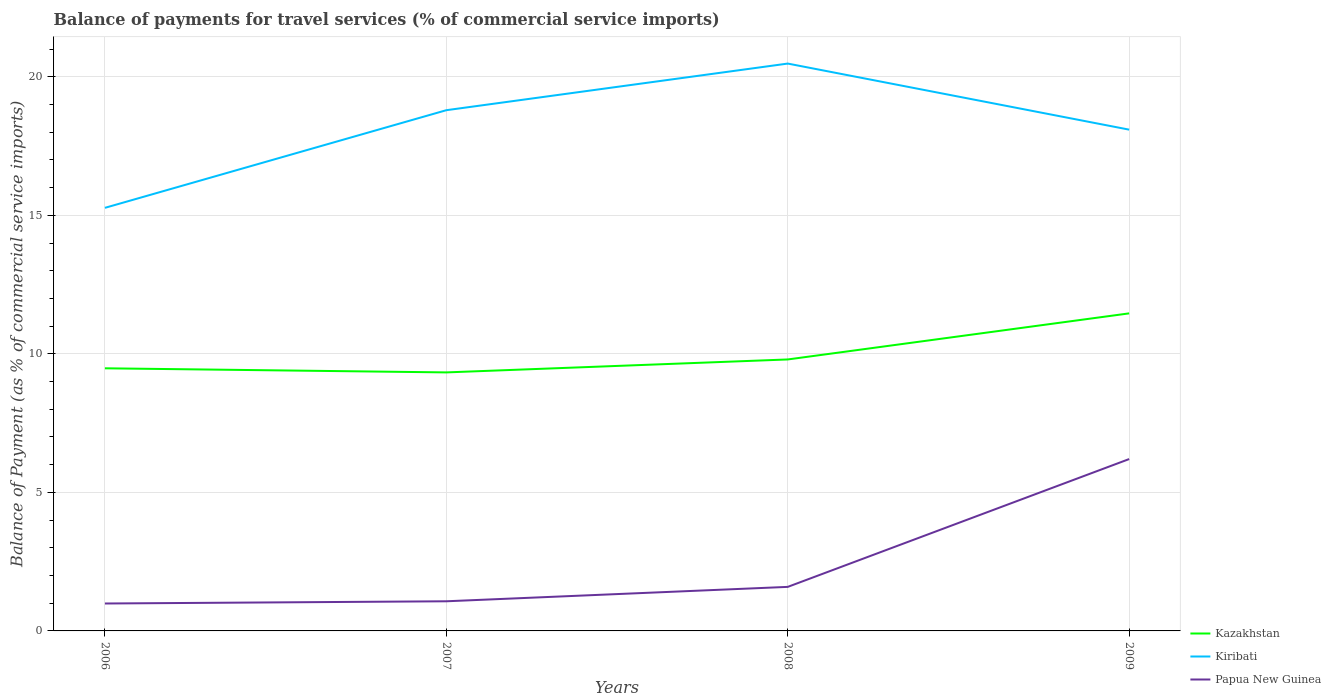Does the line corresponding to Papua New Guinea intersect with the line corresponding to Kazakhstan?
Provide a short and direct response. No. Across all years, what is the maximum balance of payments for travel services in Kazakhstan?
Keep it short and to the point. 9.33. In which year was the balance of payments for travel services in Papua New Guinea maximum?
Provide a succinct answer. 2006. What is the total balance of payments for travel services in Papua New Guinea in the graph?
Your response must be concise. -0.52. What is the difference between the highest and the second highest balance of payments for travel services in Kazakhstan?
Offer a very short reply. 2.13. What is the difference between the highest and the lowest balance of payments for travel services in Papua New Guinea?
Offer a very short reply. 1. Is the balance of payments for travel services in Kazakhstan strictly greater than the balance of payments for travel services in Papua New Guinea over the years?
Ensure brevity in your answer.  No. How many years are there in the graph?
Your answer should be compact. 4. Does the graph contain any zero values?
Provide a short and direct response. No. Where does the legend appear in the graph?
Keep it short and to the point. Bottom right. What is the title of the graph?
Make the answer very short. Balance of payments for travel services (% of commercial service imports). What is the label or title of the X-axis?
Keep it short and to the point. Years. What is the label or title of the Y-axis?
Ensure brevity in your answer.  Balance of Payment (as % of commercial service imports). What is the Balance of Payment (as % of commercial service imports) in Kazakhstan in 2006?
Give a very brief answer. 9.48. What is the Balance of Payment (as % of commercial service imports) in Kiribati in 2006?
Offer a very short reply. 15.27. What is the Balance of Payment (as % of commercial service imports) in Papua New Guinea in 2006?
Offer a very short reply. 0.99. What is the Balance of Payment (as % of commercial service imports) in Kazakhstan in 2007?
Make the answer very short. 9.33. What is the Balance of Payment (as % of commercial service imports) in Kiribati in 2007?
Provide a succinct answer. 18.79. What is the Balance of Payment (as % of commercial service imports) of Papua New Guinea in 2007?
Offer a terse response. 1.07. What is the Balance of Payment (as % of commercial service imports) of Kazakhstan in 2008?
Provide a short and direct response. 9.8. What is the Balance of Payment (as % of commercial service imports) of Kiribati in 2008?
Offer a very short reply. 20.48. What is the Balance of Payment (as % of commercial service imports) in Papua New Guinea in 2008?
Make the answer very short. 1.59. What is the Balance of Payment (as % of commercial service imports) of Kazakhstan in 2009?
Ensure brevity in your answer.  11.46. What is the Balance of Payment (as % of commercial service imports) in Kiribati in 2009?
Ensure brevity in your answer.  18.09. What is the Balance of Payment (as % of commercial service imports) in Papua New Guinea in 2009?
Make the answer very short. 6.2. Across all years, what is the maximum Balance of Payment (as % of commercial service imports) of Kazakhstan?
Provide a succinct answer. 11.46. Across all years, what is the maximum Balance of Payment (as % of commercial service imports) in Kiribati?
Offer a terse response. 20.48. Across all years, what is the maximum Balance of Payment (as % of commercial service imports) of Papua New Guinea?
Offer a very short reply. 6.2. Across all years, what is the minimum Balance of Payment (as % of commercial service imports) of Kazakhstan?
Give a very brief answer. 9.33. Across all years, what is the minimum Balance of Payment (as % of commercial service imports) of Kiribati?
Your answer should be very brief. 15.27. Across all years, what is the minimum Balance of Payment (as % of commercial service imports) in Papua New Guinea?
Your answer should be compact. 0.99. What is the total Balance of Payment (as % of commercial service imports) of Kazakhstan in the graph?
Keep it short and to the point. 40.07. What is the total Balance of Payment (as % of commercial service imports) in Kiribati in the graph?
Provide a short and direct response. 72.63. What is the total Balance of Payment (as % of commercial service imports) in Papua New Guinea in the graph?
Your response must be concise. 9.85. What is the difference between the Balance of Payment (as % of commercial service imports) in Kazakhstan in 2006 and that in 2007?
Make the answer very short. 0.15. What is the difference between the Balance of Payment (as % of commercial service imports) in Kiribati in 2006 and that in 2007?
Make the answer very short. -3.52. What is the difference between the Balance of Payment (as % of commercial service imports) in Papua New Guinea in 2006 and that in 2007?
Provide a succinct answer. -0.08. What is the difference between the Balance of Payment (as % of commercial service imports) of Kazakhstan in 2006 and that in 2008?
Keep it short and to the point. -0.32. What is the difference between the Balance of Payment (as % of commercial service imports) in Kiribati in 2006 and that in 2008?
Your response must be concise. -5.21. What is the difference between the Balance of Payment (as % of commercial service imports) of Papua New Guinea in 2006 and that in 2008?
Offer a very short reply. -0.6. What is the difference between the Balance of Payment (as % of commercial service imports) in Kazakhstan in 2006 and that in 2009?
Provide a succinct answer. -1.98. What is the difference between the Balance of Payment (as % of commercial service imports) of Kiribati in 2006 and that in 2009?
Provide a short and direct response. -2.82. What is the difference between the Balance of Payment (as % of commercial service imports) of Papua New Guinea in 2006 and that in 2009?
Make the answer very short. -5.21. What is the difference between the Balance of Payment (as % of commercial service imports) in Kazakhstan in 2007 and that in 2008?
Keep it short and to the point. -0.47. What is the difference between the Balance of Payment (as % of commercial service imports) in Kiribati in 2007 and that in 2008?
Offer a terse response. -1.68. What is the difference between the Balance of Payment (as % of commercial service imports) of Papua New Guinea in 2007 and that in 2008?
Keep it short and to the point. -0.52. What is the difference between the Balance of Payment (as % of commercial service imports) in Kazakhstan in 2007 and that in 2009?
Offer a very short reply. -2.13. What is the difference between the Balance of Payment (as % of commercial service imports) of Kiribati in 2007 and that in 2009?
Your response must be concise. 0.7. What is the difference between the Balance of Payment (as % of commercial service imports) in Papua New Guinea in 2007 and that in 2009?
Your response must be concise. -5.13. What is the difference between the Balance of Payment (as % of commercial service imports) in Kazakhstan in 2008 and that in 2009?
Ensure brevity in your answer.  -1.66. What is the difference between the Balance of Payment (as % of commercial service imports) of Kiribati in 2008 and that in 2009?
Provide a short and direct response. 2.38. What is the difference between the Balance of Payment (as % of commercial service imports) of Papua New Guinea in 2008 and that in 2009?
Your answer should be very brief. -4.61. What is the difference between the Balance of Payment (as % of commercial service imports) in Kazakhstan in 2006 and the Balance of Payment (as % of commercial service imports) in Kiribati in 2007?
Offer a terse response. -9.31. What is the difference between the Balance of Payment (as % of commercial service imports) of Kazakhstan in 2006 and the Balance of Payment (as % of commercial service imports) of Papua New Guinea in 2007?
Make the answer very short. 8.41. What is the difference between the Balance of Payment (as % of commercial service imports) in Kiribati in 2006 and the Balance of Payment (as % of commercial service imports) in Papua New Guinea in 2007?
Offer a very short reply. 14.2. What is the difference between the Balance of Payment (as % of commercial service imports) of Kazakhstan in 2006 and the Balance of Payment (as % of commercial service imports) of Kiribati in 2008?
Your answer should be very brief. -11. What is the difference between the Balance of Payment (as % of commercial service imports) in Kazakhstan in 2006 and the Balance of Payment (as % of commercial service imports) in Papua New Guinea in 2008?
Offer a very short reply. 7.89. What is the difference between the Balance of Payment (as % of commercial service imports) in Kiribati in 2006 and the Balance of Payment (as % of commercial service imports) in Papua New Guinea in 2008?
Keep it short and to the point. 13.68. What is the difference between the Balance of Payment (as % of commercial service imports) in Kazakhstan in 2006 and the Balance of Payment (as % of commercial service imports) in Kiribati in 2009?
Your answer should be very brief. -8.61. What is the difference between the Balance of Payment (as % of commercial service imports) of Kazakhstan in 2006 and the Balance of Payment (as % of commercial service imports) of Papua New Guinea in 2009?
Give a very brief answer. 3.28. What is the difference between the Balance of Payment (as % of commercial service imports) of Kiribati in 2006 and the Balance of Payment (as % of commercial service imports) of Papua New Guinea in 2009?
Your answer should be compact. 9.07. What is the difference between the Balance of Payment (as % of commercial service imports) of Kazakhstan in 2007 and the Balance of Payment (as % of commercial service imports) of Kiribati in 2008?
Keep it short and to the point. -11.15. What is the difference between the Balance of Payment (as % of commercial service imports) of Kazakhstan in 2007 and the Balance of Payment (as % of commercial service imports) of Papua New Guinea in 2008?
Provide a short and direct response. 7.74. What is the difference between the Balance of Payment (as % of commercial service imports) in Kiribati in 2007 and the Balance of Payment (as % of commercial service imports) in Papua New Guinea in 2008?
Give a very brief answer. 17.2. What is the difference between the Balance of Payment (as % of commercial service imports) of Kazakhstan in 2007 and the Balance of Payment (as % of commercial service imports) of Kiribati in 2009?
Give a very brief answer. -8.76. What is the difference between the Balance of Payment (as % of commercial service imports) in Kazakhstan in 2007 and the Balance of Payment (as % of commercial service imports) in Papua New Guinea in 2009?
Your answer should be compact. 3.13. What is the difference between the Balance of Payment (as % of commercial service imports) in Kiribati in 2007 and the Balance of Payment (as % of commercial service imports) in Papua New Guinea in 2009?
Your answer should be very brief. 12.59. What is the difference between the Balance of Payment (as % of commercial service imports) in Kazakhstan in 2008 and the Balance of Payment (as % of commercial service imports) in Kiribati in 2009?
Make the answer very short. -8.29. What is the difference between the Balance of Payment (as % of commercial service imports) in Kazakhstan in 2008 and the Balance of Payment (as % of commercial service imports) in Papua New Guinea in 2009?
Give a very brief answer. 3.59. What is the difference between the Balance of Payment (as % of commercial service imports) in Kiribati in 2008 and the Balance of Payment (as % of commercial service imports) in Papua New Guinea in 2009?
Keep it short and to the point. 14.27. What is the average Balance of Payment (as % of commercial service imports) of Kazakhstan per year?
Provide a short and direct response. 10.02. What is the average Balance of Payment (as % of commercial service imports) in Kiribati per year?
Offer a very short reply. 18.16. What is the average Balance of Payment (as % of commercial service imports) of Papua New Guinea per year?
Provide a short and direct response. 2.46. In the year 2006, what is the difference between the Balance of Payment (as % of commercial service imports) of Kazakhstan and Balance of Payment (as % of commercial service imports) of Kiribati?
Keep it short and to the point. -5.79. In the year 2006, what is the difference between the Balance of Payment (as % of commercial service imports) of Kazakhstan and Balance of Payment (as % of commercial service imports) of Papua New Guinea?
Provide a succinct answer. 8.49. In the year 2006, what is the difference between the Balance of Payment (as % of commercial service imports) of Kiribati and Balance of Payment (as % of commercial service imports) of Papua New Guinea?
Keep it short and to the point. 14.28. In the year 2007, what is the difference between the Balance of Payment (as % of commercial service imports) of Kazakhstan and Balance of Payment (as % of commercial service imports) of Kiribati?
Offer a very short reply. -9.46. In the year 2007, what is the difference between the Balance of Payment (as % of commercial service imports) in Kazakhstan and Balance of Payment (as % of commercial service imports) in Papua New Guinea?
Your answer should be very brief. 8.26. In the year 2007, what is the difference between the Balance of Payment (as % of commercial service imports) in Kiribati and Balance of Payment (as % of commercial service imports) in Papua New Guinea?
Keep it short and to the point. 17.72. In the year 2008, what is the difference between the Balance of Payment (as % of commercial service imports) in Kazakhstan and Balance of Payment (as % of commercial service imports) in Kiribati?
Your answer should be very brief. -10.68. In the year 2008, what is the difference between the Balance of Payment (as % of commercial service imports) of Kazakhstan and Balance of Payment (as % of commercial service imports) of Papua New Guinea?
Make the answer very short. 8.21. In the year 2008, what is the difference between the Balance of Payment (as % of commercial service imports) in Kiribati and Balance of Payment (as % of commercial service imports) in Papua New Guinea?
Ensure brevity in your answer.  18.89. In the year 2009, what is the difference between the Balance of Payment (as % of commercial service imports) in Kazakhstan and Balance of Payment (as % of commercial service imports) in Kiribati?
Ensure brevity in your answer.  -6.63. In the year 2009, what is the difference between the Balance of Payment (as % of commercial service imports) of Kazakhstan and Balance of Payment (as % of commercial service imports) of Papua New Guinea?
Your answer should be very brief. 5.26. In the year 2009, what is the difference between the Balance of Payment (as % of commercial service imports) of Kiribati and Balance of Payment (as % of commercial service imports) of Papua New Guinea?
Give a very brief answer. 11.89. What is the ratio of the Balance of Payment (as % of commercial service imports) in Kazakhstan in 2006 to that in 2007?
Offer a very short reply. 1.02. What is the ratio of the Balance of Payment (as % of commercial service imports) in Kiribati in 2006 to that in 2007?
Keep it short and to the point. 0.81. What is the ratio of the Balance of Payment (as % of commercial service imports) in Papua New Guinea in 2006 to that in 2007?
Ensure brevity in your answer.  0.93. What is the ratio of the Balance of Payment (as % of commercial service imports) of Kazakhstan in 2006 to that in 2008?
Provide a short and direct response. 0.97. What is the ratio of the Balance of Payment (as % of commercial service imports) in Kiribati in 2006 to that in 2008?
Provide a succinct answer. 0.75. What is the ratio of the Balance of Payment (as % of commercial service imports) in Papua New Guinea in 2006 to that in 2008?
Your response must be concise. 0.62. What is the ratio of the Balance of Payment (as % of commercial service imports) of Kazakhstan in 2006 to that in 2009?
Keep it short and to the point. 0.83. What is the ratio of the Balance of Payment (as % of commercial service imports) of Kiribati in 2006 to that in 2009?
Give a very brief answer. 0.84. What is the ratio of the Balance of Payment (as % of commercial service imports) of Papua New Guinea in 2006 to that in 2009?
Ensure brevity in your answer.  0.16. What is the ratio of the Balance of Payment (as % of commercial service imports) of Kazakhstan in 2007 to that in 2008?
Make the answer very short. 0.95. What is the ratio of the Balance of Payment (as % of commercial service imports) in Kiribati in 2007 to that in 2008?
Give a very brief answer. 0.92. What is the ratio of the Balance of Payment (as % of commercial service imports) of Papua New Guinea in 2007 to that in 2008?
Your answer should be very brief. 0.67. What is the ratio of the Balance of Payment (as % of commercial service imports) of Kazakhstan in 2007 to that in 2009?
Ensure brevity in your answer.  0.81. What is the ratio of the Balance of Payment (as % of commercial service imports) in Kiribati in 2007 to that in 2009?
Your answer should be very brief. 1.04. What is the ratio of the Balance of Payment (as % of commercial service imports) of Papua New Guinea in 2007 to that in 2009?
Ensure brevity in your answer.  0.17. What is the ratio of the Balance of Payment (as % of commercial service imports) in Kazakhstan in 2008 to that in 2009?
Make the answer very short. 0.85. What is the ratio of the Balance of Payment (as % of commercial service imports) of Kiribati in 2008 to that in 2009?
Your answer should be compact. 1.13. What is the ratio of the Balance of Payment (as % of commercial service imports) in Papua New Guinea in 2008 to that in 2009?
Ensure brevity in your answer.  0.26. What is the difference between the highest and the second highest Balance of Payment (as % of commercial service imports) in Kazakhstan?
Your response must be concise. 1.66. What is the difference between the highest and the second highest Balance of Payment (as % of commercial service imports) of Kiribati?
Your answer should be compact. 1.68. What is the difference between the highest and the second highest Balance of Payment (as % of commercial service imports) of Papua New Guinea?
Ensure brevity in your answer.  4.61. What is the difference between the highest and the lowest Balance of Payment (as % of commercial service imports) in Kazakhstan?
Make the answer very short. 2.13. What is the difference between the highest and the lowest Balance of Payment (as % of commercial service imports) in Kiribati?
Your answer should be compact. 5.21. What is the difference between the highest and the lowest Balance of Payment (as % of commercial service imports) in Papua New Guinea?
Provide a short and direct response. 5.21. 